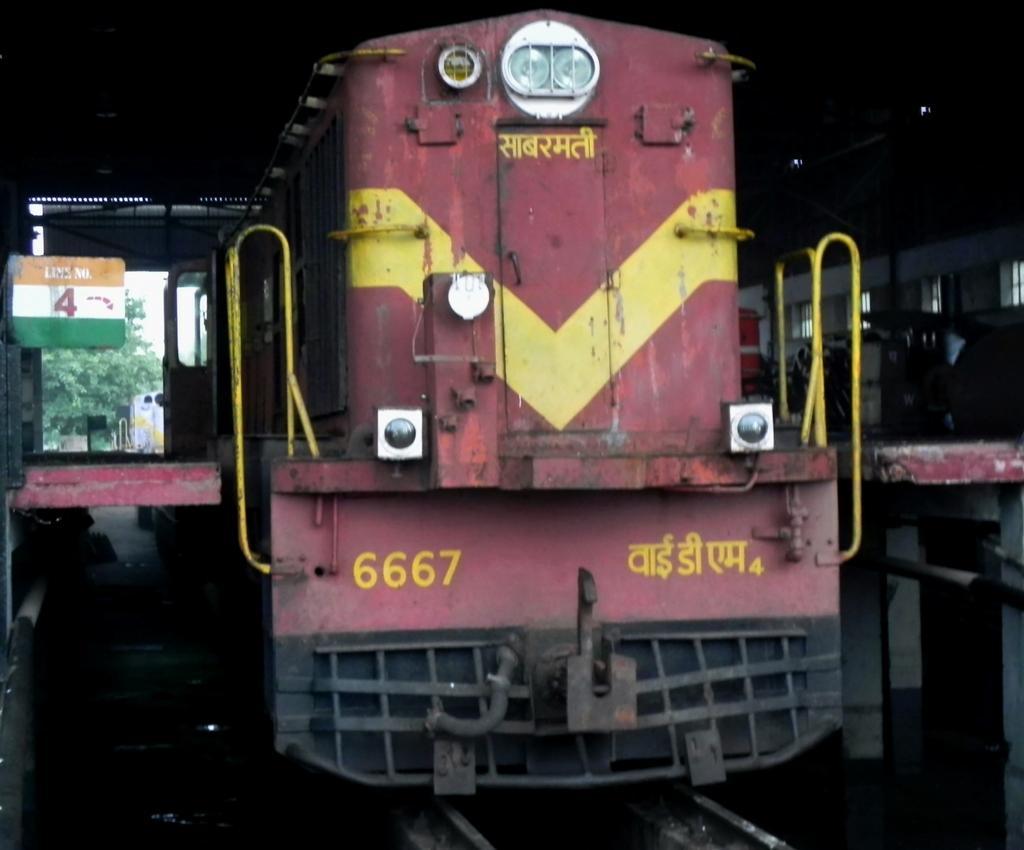Please provide a concise description of this image. In the foreground I can see trains on the track. In the background I can see trees and the sky. This image is taken may be during a day. 